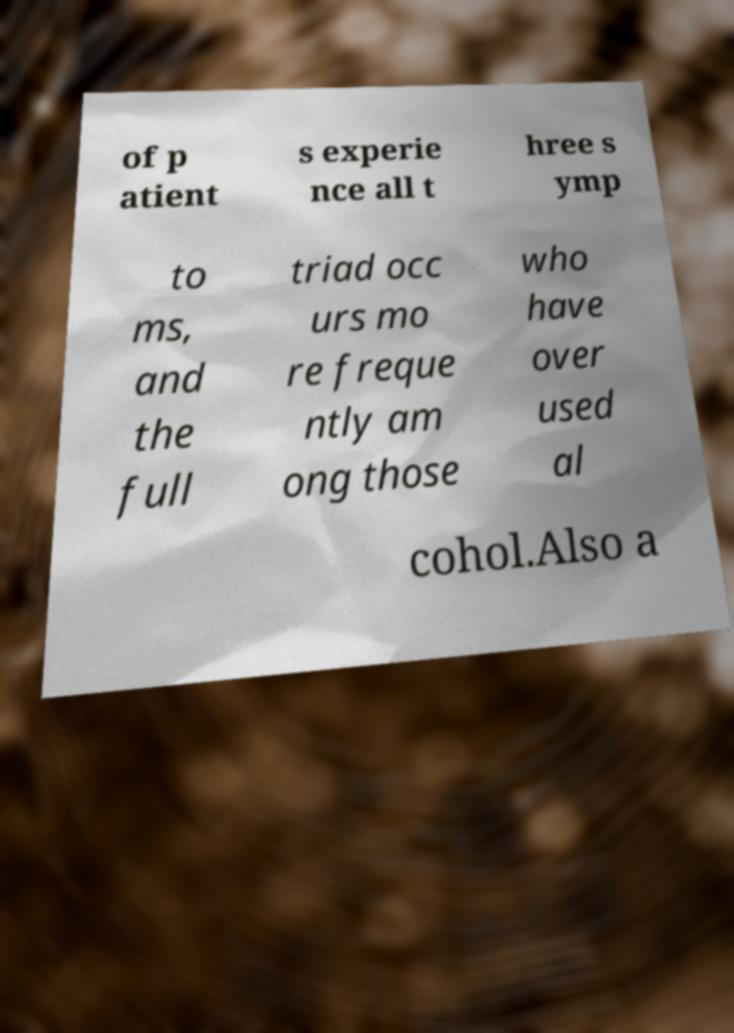For documentation purposes, I need the text within this image transcribed. Could you provide that? of p atient s experie nce all t hree s ymp to ms, and the full triad occ urs mo re freque ntly am ong those who have over used al cohol.Also a 